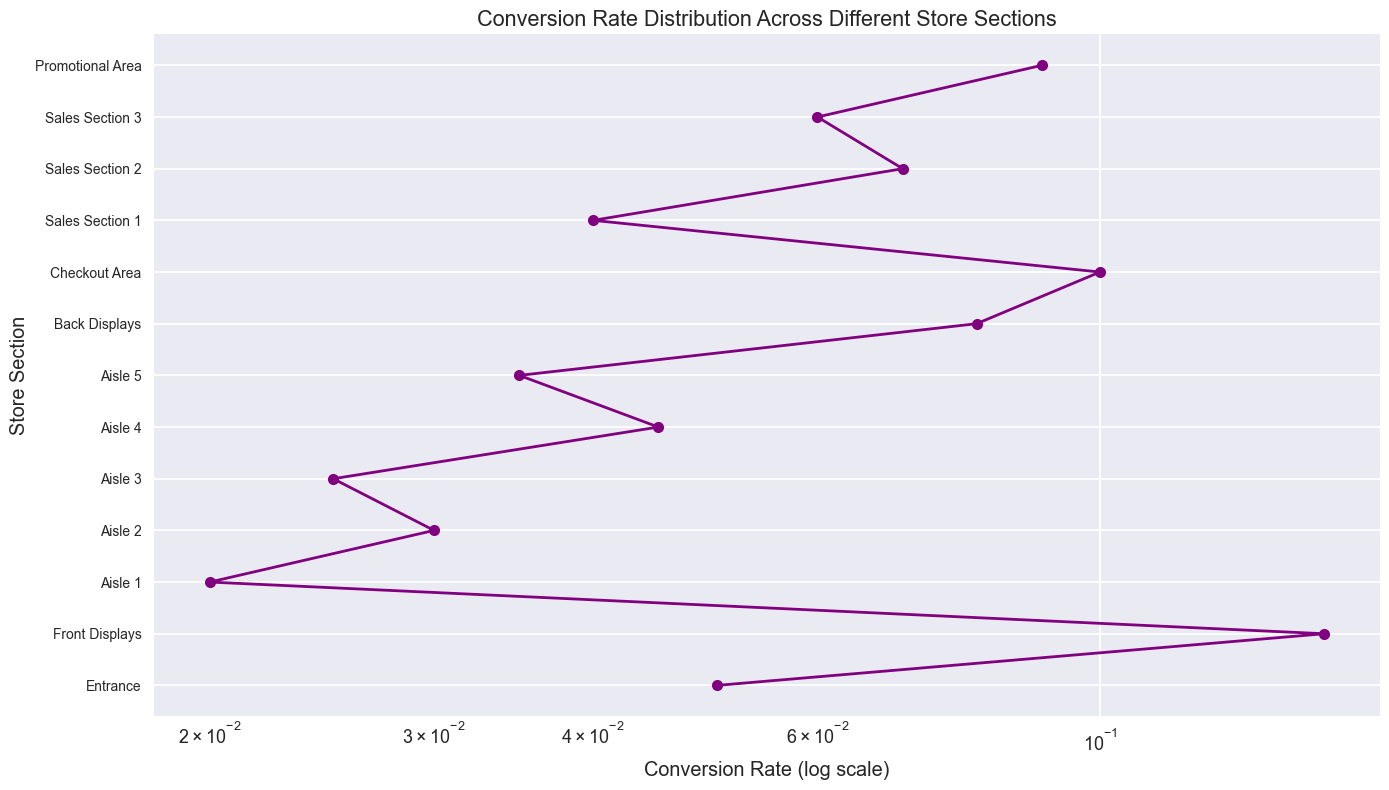What is the section with the highest conversion rate? The section with the highest conversion rate is the one positioned farthest to the right on the x-axis since the x-axis is in log scale. From the chart, this is the 'Front Displays' section.
Answer: Front Displays Which section has a higher conversion rate, 'Aisle 2' or 'Aisle 4'? Comparing the 'Aisle 2' and 'Aisle 4' data points, 'Aisle 4' is further to the right on the x-axis, indicating a higher conversion rate.
Answer: Aisle 4 What is the difference in conversion rate between 'Front Displays' and 'Entrance'? The conversion rate for 'Front Displays' is 0.15 and for 'Entrance' is 0.05. The difference is 0.15 - 0.05.
Answer: 0.10 What is the average conversion rate for 'Aisle 1', 'Aisle 2', and 'Aisle 3'? The conversion rates for 'Aisle 1', 'Aisle 2', and 'Aisle 3' are 0.02, 0.03, and 0.025 respectively. The average is calculated as (0.02 + 0.03 + 0.025)/3.
Answer: 0.025 Which section has the lowest conversion rate? The section with the lowest conversion rate is the one positioned farthest to the left on the x-axis in log scale. From the chart, this is the 'Aisle 1' section.
Answer: Aisle 1 How does the conversion rate of 'Back Displays' compare to 'Sales Section 1'? The conversion rate for 'Back Displays' is further to the right on the x-axis than 'Sales Section 1', indicating that 'Back Displays' has a higher conversion rate.
Answer: Back Displays What is the median conversion rate of all store sections? To find the median conversion rate, list all conversion rates in ascending order: 0.02, 0.025, 0.03, 0.035, 0.04, 0.045, 0.05, 0.06, 0.07, 0.08, 0.09, 0.10, 0.15. The median is the middle value, which is 0.045.
Answer: 0.045 Are there any sections with equal conversion rates? Scanning the chart, each section has a unique position on the x-axis in the log scale, indicating that each section has a distinct conversion rate.
Answer: No 